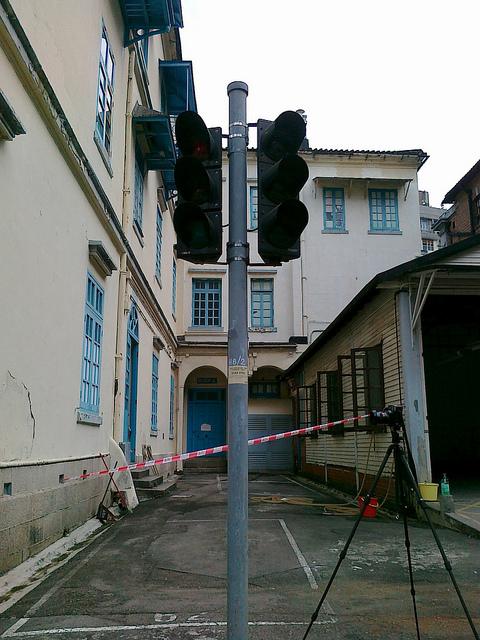How many windows are there?
Write a very short answer. 14. What is the weather like?
Give a very brief answer. Cloudy. Is it raining?
Quick response, please. No. Is this a street sign?
Be succinct. No. How many lights are on the streetlight?
Keep it brief. 6. What is the black paved surface?
Write a very short answer. Sidewalk. Is the stoplight working?
Be succinct. No. Is the window open?
Answer briefly. No. What color is the street light?
Concise answer only. Black. Is this a modern building?
Write a very short answer. No. Can a little car park here?
Write a very short answer. Yes. What color are the windows?
Concise answer only. Blue. How many windows are visible on the White House?
Write a very short answer. 13. How many unlit street lights can be seen?
Be succinct. 2. What color is the door?
Answer briefly. Blue. Does the light work?
Write a very short answer. No. Is the traffic light functioning?
Quick response, please. No. Is this a city street?
Be succinct. No. 